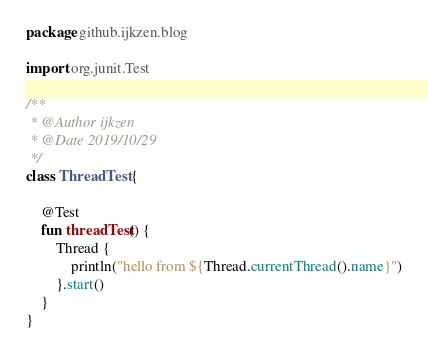Convert code to text. <code><loc_0><loc_0><loc_500><loc_500><_Kotlin_>package github.ijkzen.blog

import org.junit.Test

/**
 * @Author ijkzen
 * @Date 2019/10/29
 */
class ThreadTest {

    @Test
    fun threadTest() {
        Thread {
            println("hello from ${Thread.currentThread().name}")
        }.start()
    }
}</code> 